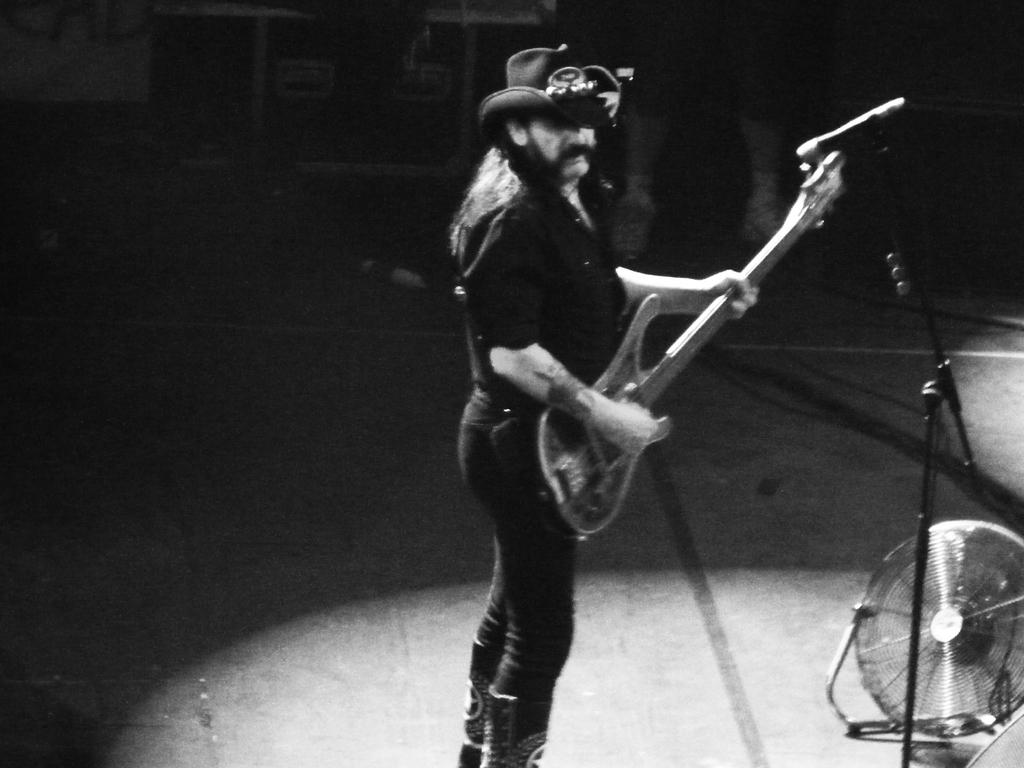Who is the main subject in the image? There is a man in the image. What is the man wearing on his head? The man is wearing a hat. What object is the man holding in the image? The man is holding a guitar. What is the man doing with the guitar? The man is playing the guitar. What type of oatmeal is the man eating in the image? There is no oatmeal present in the image; the man is playing a guitar. 